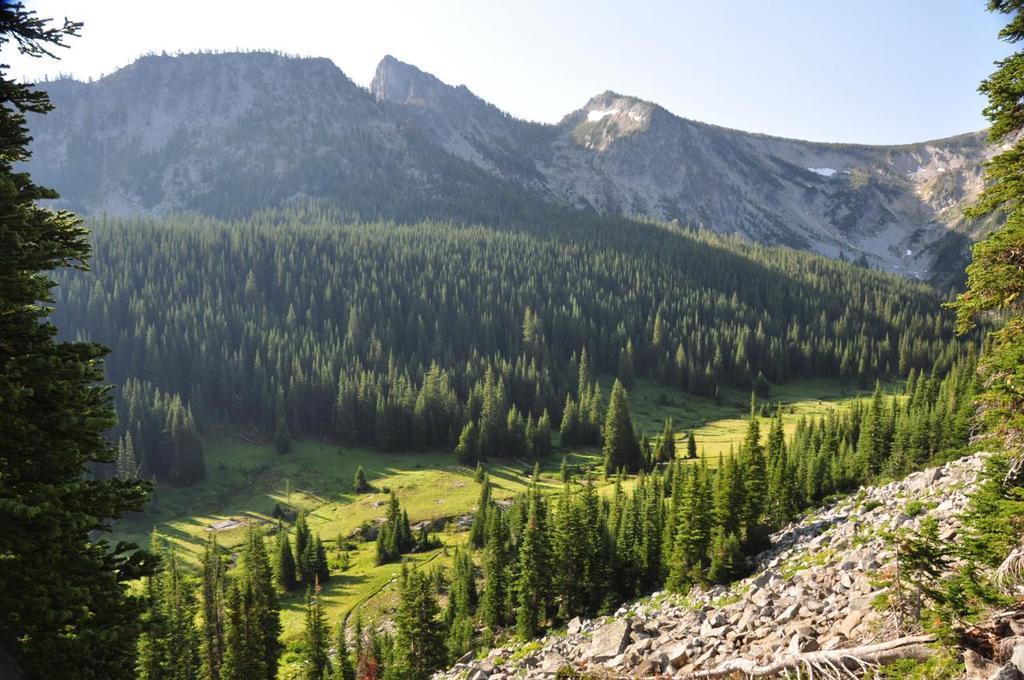How would you summarize this image in a sentence or two? This picture is clicked outside the city. In the foreground we can see the trees and the stones. In the background there is a sky, hills and the trees. 